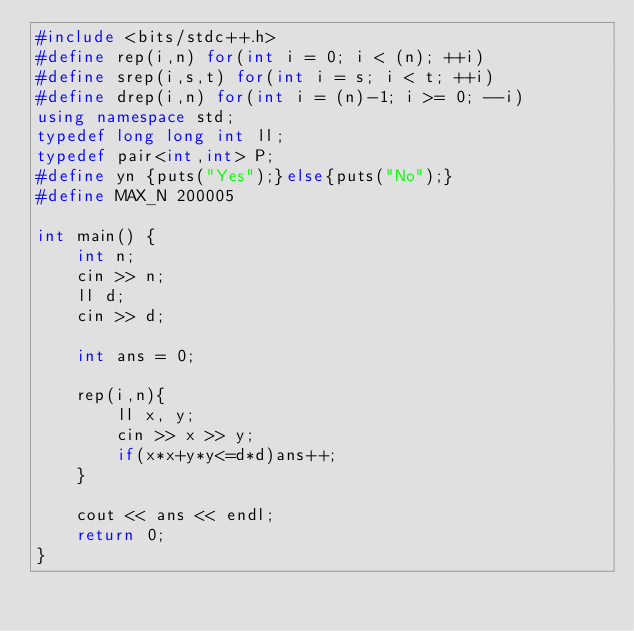Convert code to text. <code><loc_0><loc_0><loc_500><loc_500><_C++_>#include <bits/stdc++.h>
#define rep(i,n) for(int i = 0; i < (n); ++i)
#define srep(i,s,t) for(int i = s; i < t; ++i)
#define drep(i,n) for(int i = (n)-1; i >= 0; --i)
using namespace std;
typedef long long int ll;
typedef pair<int,int> P;
#define yn {puts("Yes");}else{puts("No");}
#define MAX_N 200005

int main() {
    int n;
    cin >> n;
    ll d;
    cin >> d;

    int ans = 0;

    rep(i,n){
        ll x, y;
        cin >> x >> y;
        if(x*x+y*y<=d*d)ans++;
    }

    cout << ans << endl;
    return 0;
}


</code> 